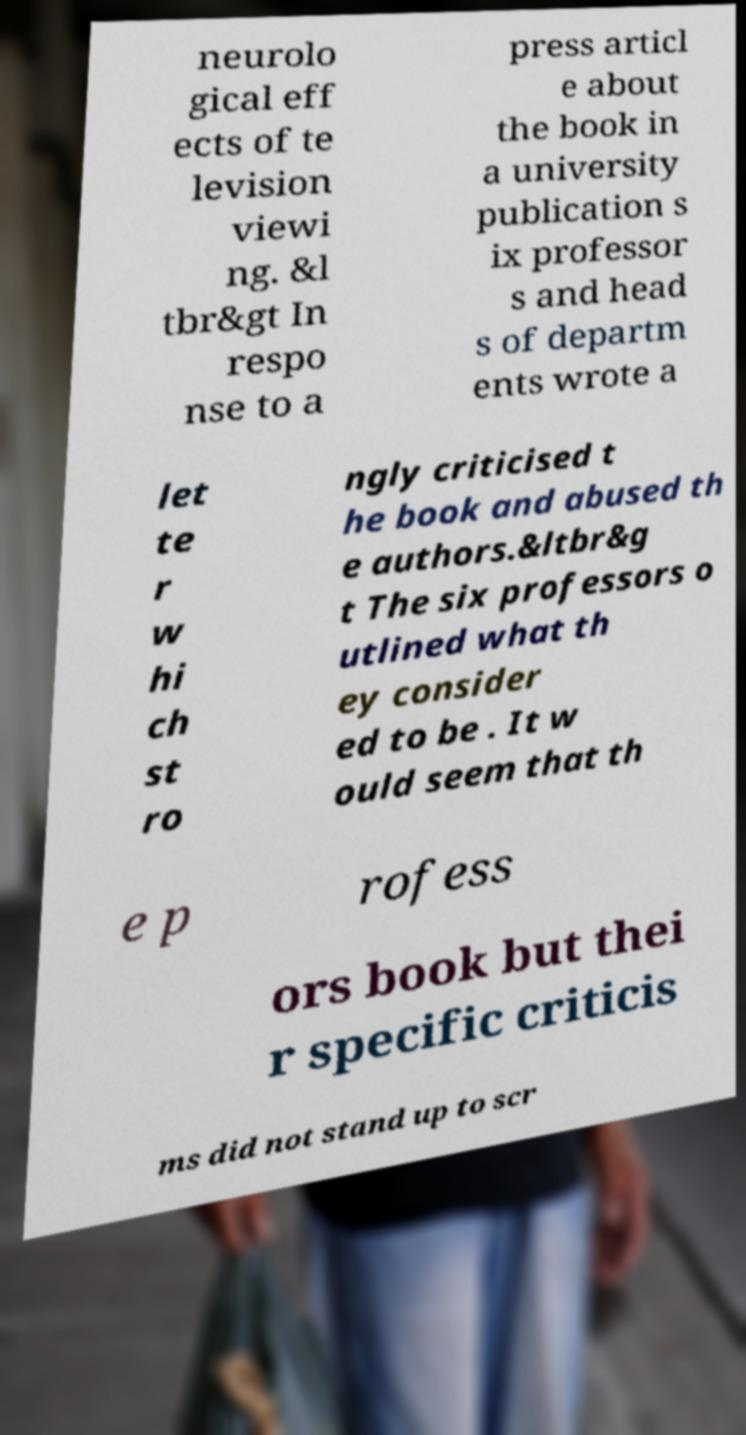Can you read and provide the text displayed in the image?This photo seems to have some interesting text. Can you extract and type it out for me? neurolo gical eff ects of te levision viewi ng. &l tbr&gt In respo nse to a press articl e about the book in a university publication s ix professor s and head s of departm ents wrote a let te r w hi ch st ro ngly criticised t he book and abused th e authors.&ltbr&g t The six professors o utlined what th ey consider ed to be . It w ould seem that th e p rofess ors book but thei r specific criticis ms did not stand up to scr 